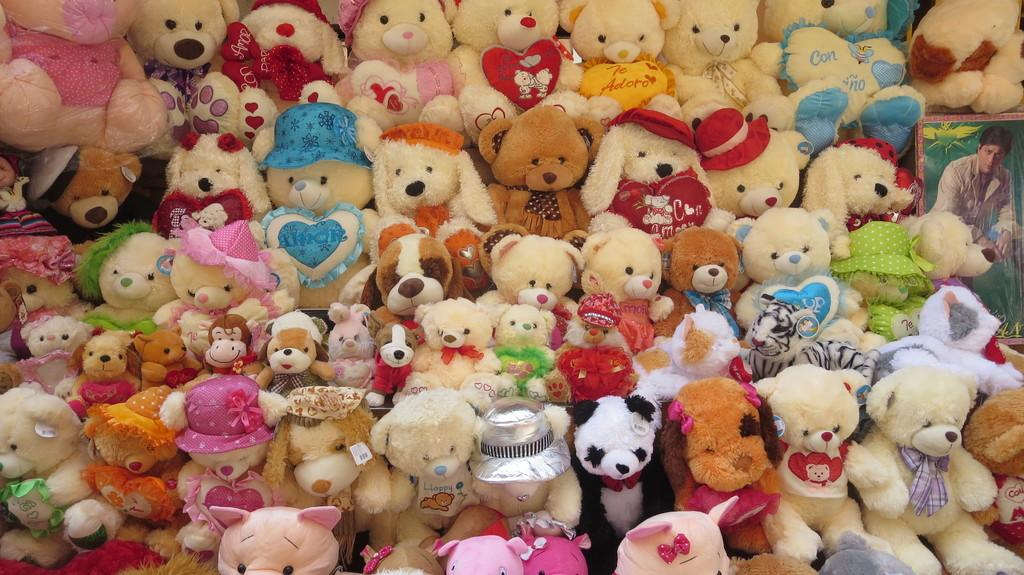What is the main subject in the center of the image? There are many dolls in the center of the image. What can be seen on the right side of the image? There is a wallpaper on the right side of the image. How many heads can be seen kissing on the bridge in the image? There is no bridge or heads kissing in the image; it only features dolls and wallpaper. 